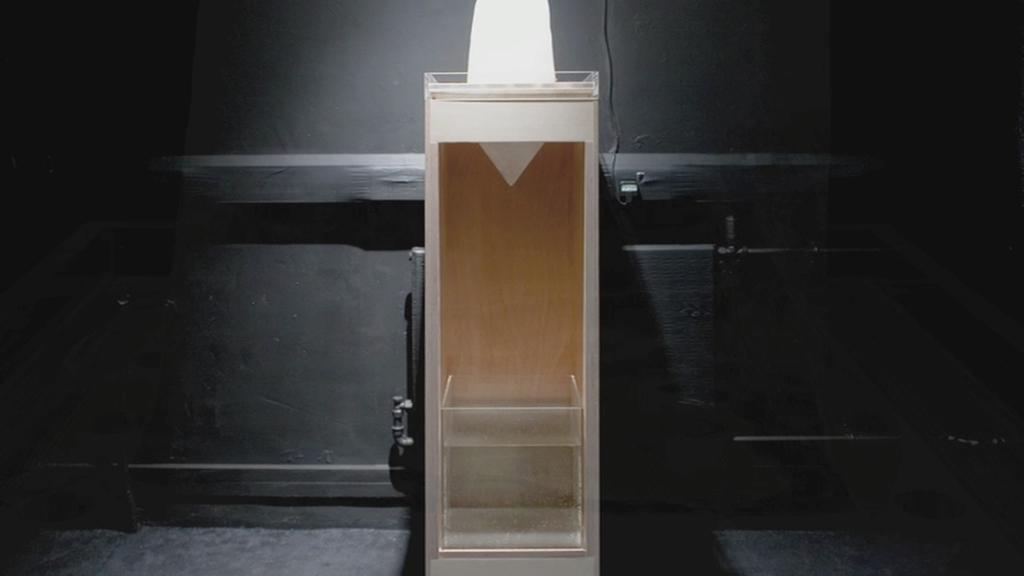Describe this image in one or two sentences. In the middle of the image, there is a white color object placed in a box which is covered with a glass. In the background, there is a wall. And the background is dark in color. 